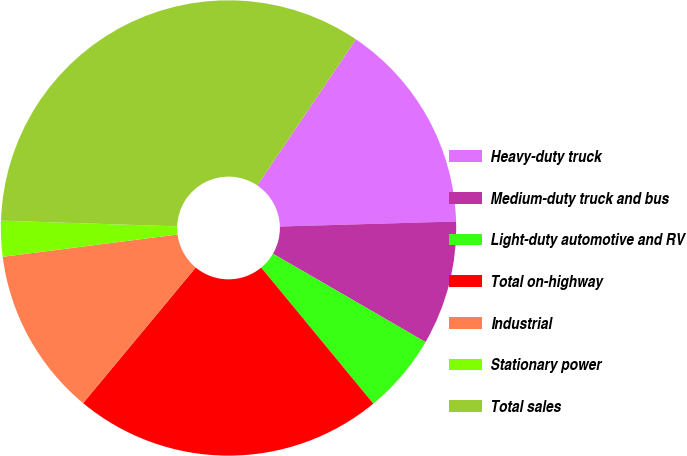Convert chart to OTSL. <chart><loc_0><loc_0><loc_500><loc_500><pie_chart><fcel>Heavy-duty truck<fcel>Medium-duty truck and bus<fcel>Light-duty automotive and RV<fcel>Total on-highway<fcel>Industrial<fcel>Stationary power<fcel>Total sales<nl><fcel>15.09%<fcel>8.81%<fcel>5.67%<fcel>22.0%<fcel>11.95%<fcel>2.53%<fcel>33.94%<nl></chart> 